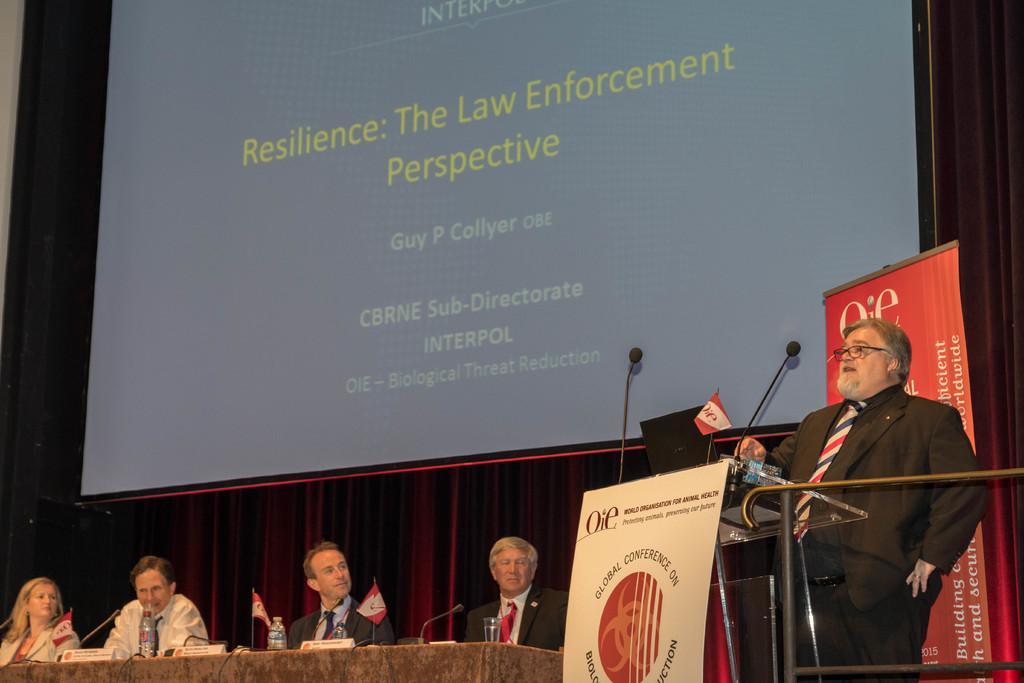Describe this image in one or two sentences. In the picture I can see a person wearing black suit is standing and speaking in front of a mic which is placed on the table in front of it and there are few persons sitting beside him and there is a table in front of them which has few mice and some other objects on it and there is a projected image in the background. 